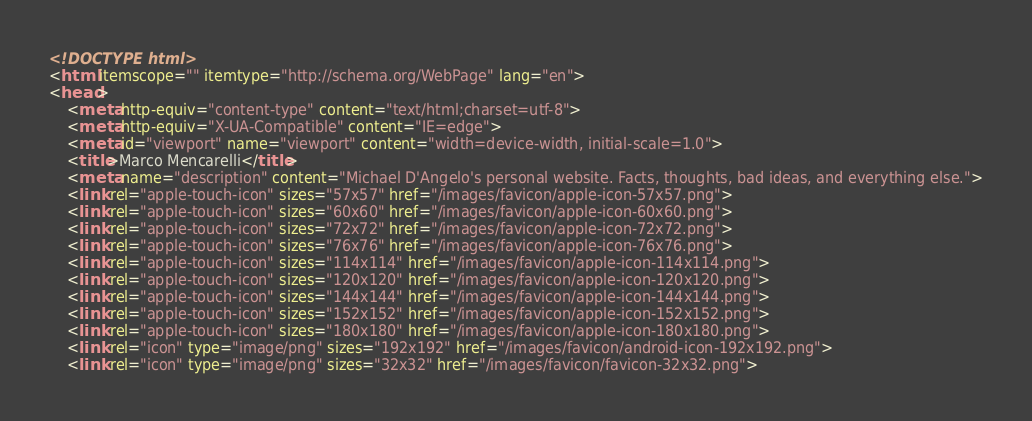<code> <loc_0><loc_0><loc_500><loc_500><_HTML_><!DOCTYPE html>
<html itemscope="" itemtype="http://schema.org/WebPage" lang="en">
<head>
    <meta http-equiv="content-type" content="text/html;charset=utf-8">
    <meta http-equiv="X-UA-Compatible" content="IE=edge">
    <meta id="viewport" name="viewport" content="width=device-width, initial-scale=1.0">
    <title>Marco Mencarelli</title>
    <meta name="description" content="Michael D'Angelo's personal website. Facts, thoughts, bad ideas, and everything else.">
    <link rel="apple-touch-icon" sizes="57x57" href="/images/favicon/apple-icon-57x57.png">
    <link rel="apple-touch-icon" sizes="60x60" href="/images/favicon/apple-icon-60x60.png">
    <link rel="apple-touch-icon" sizes="72x72" href="/images/favicon/apple-icon-72x72.png">
    <link rel="apple-touch-icon" sizes="76x76" href="/images/favicon/apple-icon-76x76.png">
    <link rel="apple-touch-icon" sizes="114x114" href="/images/favicon/apple-icon-114x114.png">
    <link rel="apple-touch-icon" sizes="120x120" href="/images/favicon/apple-icon-120x120.png">
    <link rel="apple-touch-icon" sizes="144x144" href="/images/favicon/apple-icon-144x144.png">
    <link rel="apple-touch-icon" sizes="152x152" href="/images/favicon/apple-icon-152x152.png">
    <link rel="apple-touch-icon" sizes="180x180" href="/images/favicon/apple-icon-180x180.png">
    <link rel="icon" type="image/png" sizes="192x192" href="/images/favicon/android-icon-192x192.png">
    <link rel="icon" type="image/png" sizes="32x32" href="/images/favicon/favicon-32x32.png"></code> 